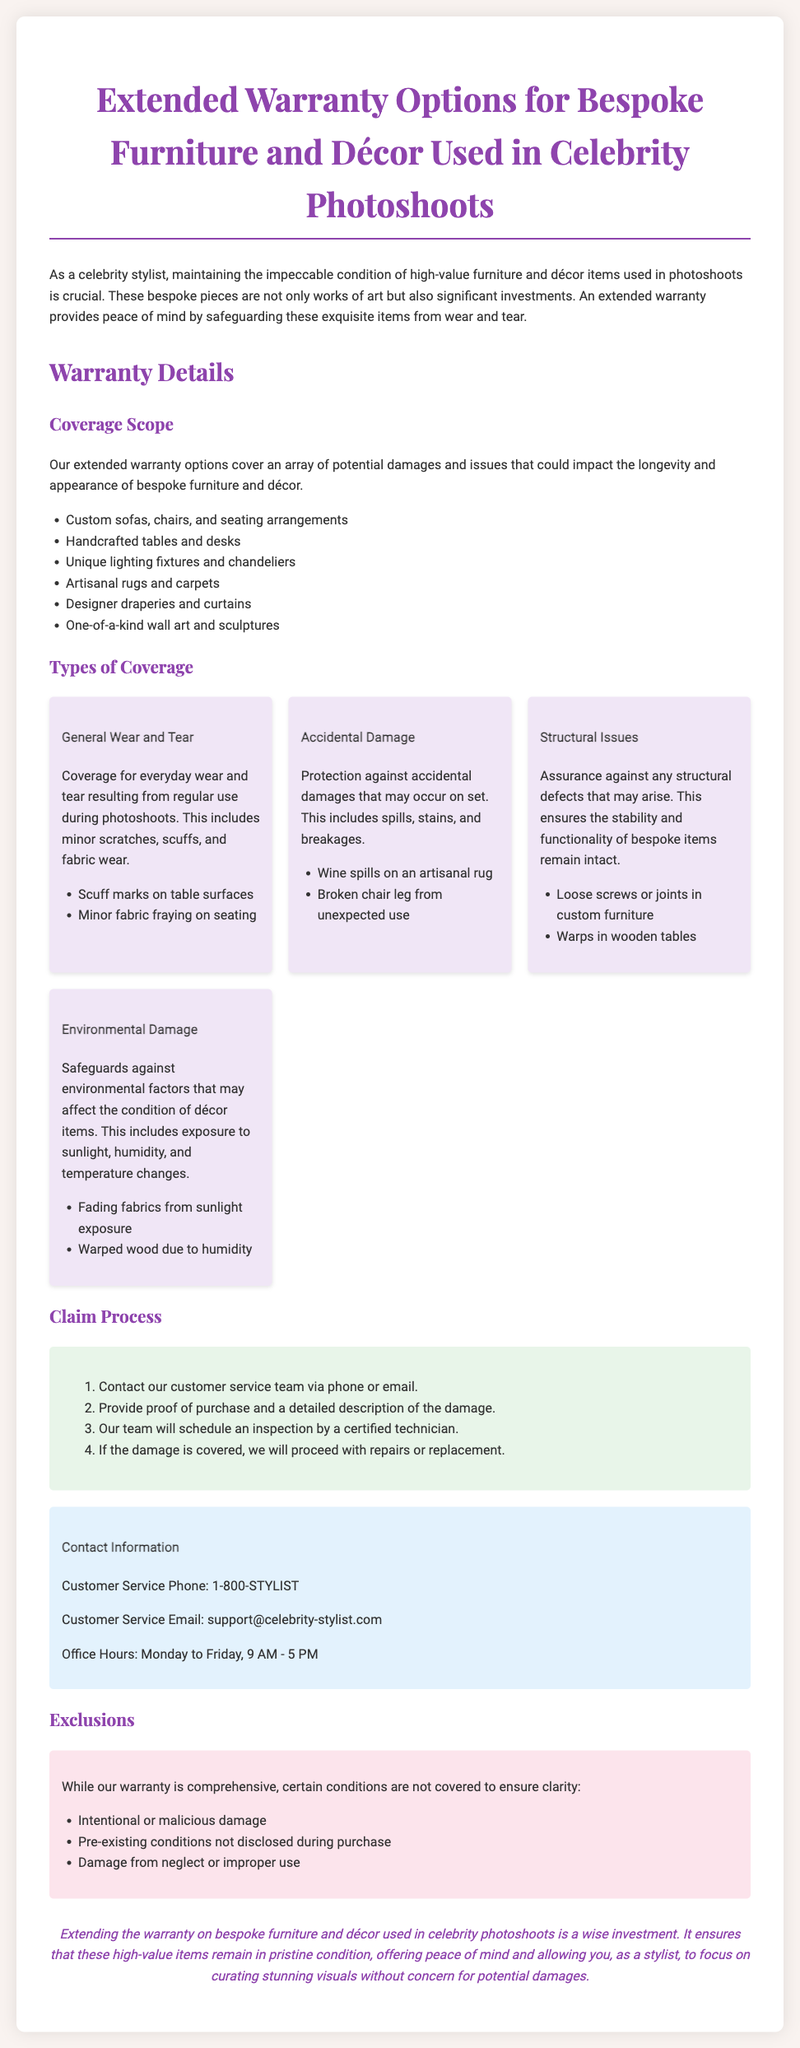What is the warranty coverage scope for bespoke furniture? The warranty coverage scope includes custom sofas, handcrafted tables, unique lighting fixtures, artisanal rugs, designer draperies, and one-of-a-kind wall art.
Answer: Custom sofas, handcrafted tables, unique lighting fixtures, artisanal rugs, designer draperies, one-of-a-kind wall art What type of damage does the warranty cover? The warranty covers general wear and tear, accidental damage, structural issues, and environmental damage.
Answer: General wear and tear, accidental damage, structural issues, environmental damage How many types of coverage are specified in the document? The document details four types of coverage for the warranty.
Answer: Four What is one example of accidental damage covered? The document provides the example of wine spills on an artisanal rug as accidental damage.
Answer: Wine spills on an artisanal rug What process must be followed to claim the warranty? The process requires contacting customer service, providing proof of purchase, scheduling an inspection, and if covered, proceeding with repairs or replacement.
Answer: Contact customer service, provide proof, schedule inspection, repairs or replacement What is excluded from the warranty coverage? Exclusions include intentional damage, pre-existing conditions, and damage from neglect.
Answer: Intentional or malicious damage, pre-existing conditions, neglect What hours is customer service available? The customer service office hours are listed as Monday to Friday, 9 AM to 5 PM.
Answer: Monday to Friday, 9 AM - 5 PM What is the customer service phone number? The document provides the customer service phone number for inquiries related to the warranty.
Answer: 1-800-STYLIST 